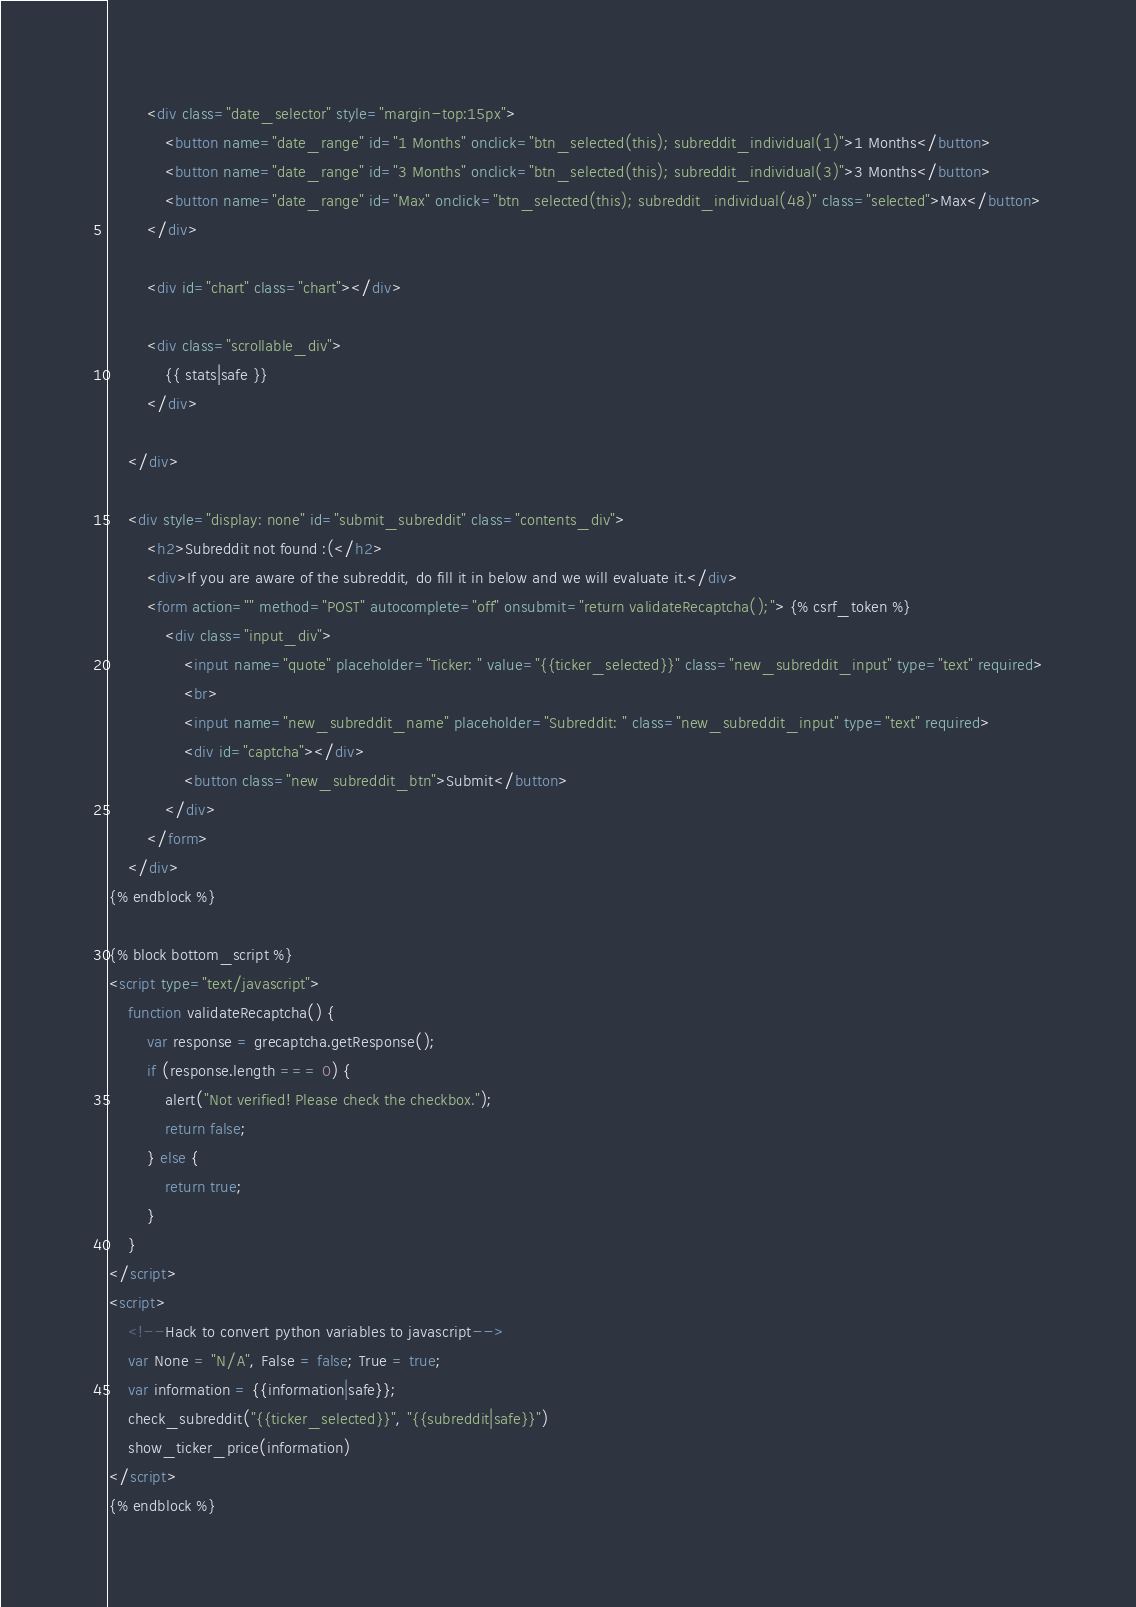<code> <loc_0><loc_0><loc_500><loc_500><_HTML_>        <div class="date_selector" style="margin-top:15px">
            <button name="date_range" id="1 Months" onclick="btn_selected(this); subreddit_individual(1)">1 Months</button>
            <button name="date_range" id="3 Months" onclick="btn_selected(this); subreddit_individual(3)">3 Months</button>
            <button name="date_range" id="Max" onclick="btn_selected(this); subreddit_individual(48)" class="selected">Max</button>
        </div>

        <div id="chart" class="chart"></div>

        <div class="scrollable_div">
            {{ stats|safe }}
        </div>

    </div>

    <div style="display: none" id="submit_subreddit" class="contents_div">
        <h2>Subreddit not found :(</h2>
        <div>If you are aware of the subreddit, do fill it in below and we will evaluate it.</div>
        <form action="" method="POST" autocomplete="off" onsubmit="return validateRecaptcha();"> {% csrf_token %}
            <div class="input_div">
                <input name="quote" placeholder="Ticker: " value="{{ticker_selected}}" class="new_subreddit_input" type="text" required>
                <br>
                <input name="new_subreddit_name" placeholder="Subreddit: " class="new_subreddit_input" type="text" required>
                <div id="captcha"></div>
                <button class="new_subreddit_btn">Submit</button>
            </div>
        </form>
    </div>
{% endblock %}

{% block bottom_script %}
<script type="text/javascript">
    function validateRecaptcha() {
        var response = grecaptcha.getResponse();
        if (response.length === 0) {
            alert("Not verified! Please check the checkbox.");
            return false;
        } else {
            return true;
        }
    }
</script>
<script>
    <!--Hack to convert python variables to javascript-->
    var None = "N/A", False = false; True = true;
    var information = {{information|safe}};
    check_subreddit("{{ticker_selected}}", "{{subreddit|safe}}")
    show_ticker_price(information)
</script>
{% endblock %}
</code> 